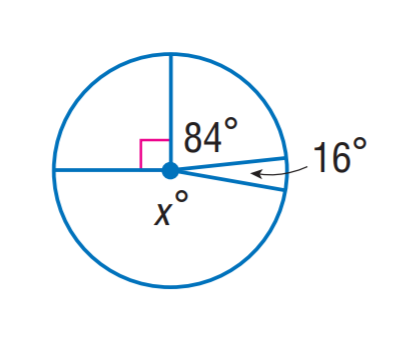Answer the mathemtical geometry problem and directly provide the correct option letter.
Question: Find x.
Choices: A: 168 B: 170 C: 172 D: 174 B 